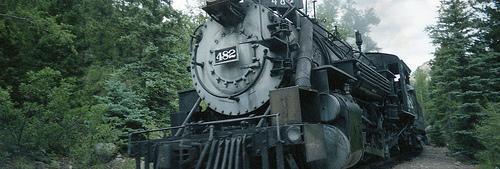How many trains are in the picture?
Give a very brief answer. 1. 